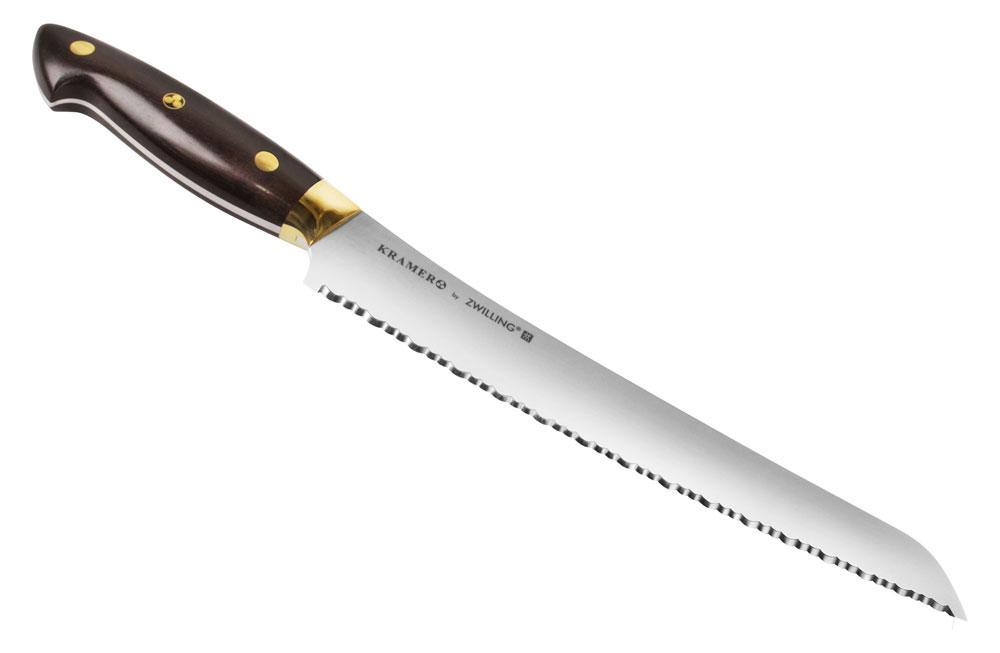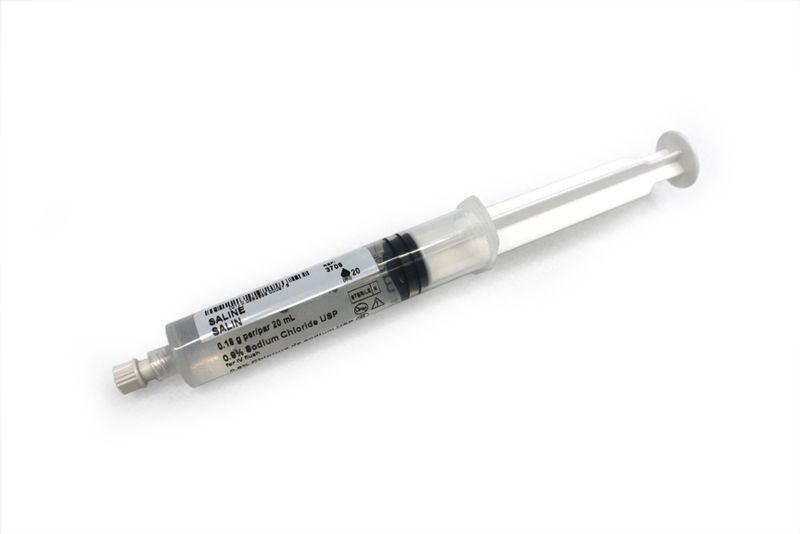The first image is the image on the left, the second image is the image on the right. Evaluate the accuracy of this statement regarding the images: "there is at least one syringe in the image on the left". Is it true? Answer yes or no. No. The first image is the image on the left, the second image is the image on the right. Examine the images to the left and right. Is the description "One of the syringes has a grey plunger." accurate? Answer yes or no. Yes. 